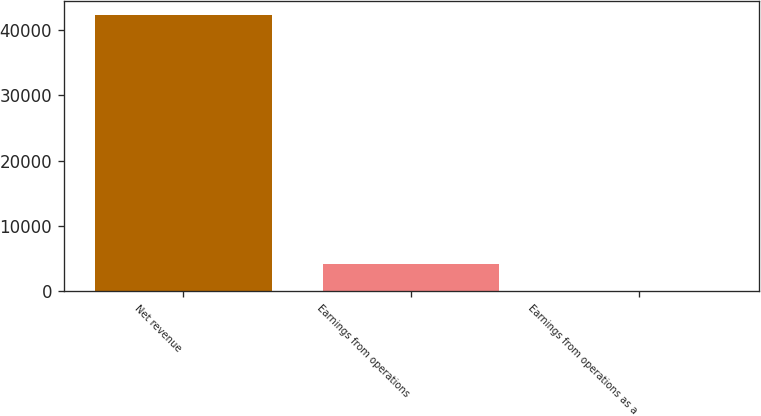Convert chart. <chart><loc_0><loc_0><loc_500><loc_500><bar_chart><fcel>Net revenue<fcel>Earnings from operations<fcel>Earnings from operations as a<nl><fcel>42295<fcel>4234.54<fcel>5.6<nl></chart> 